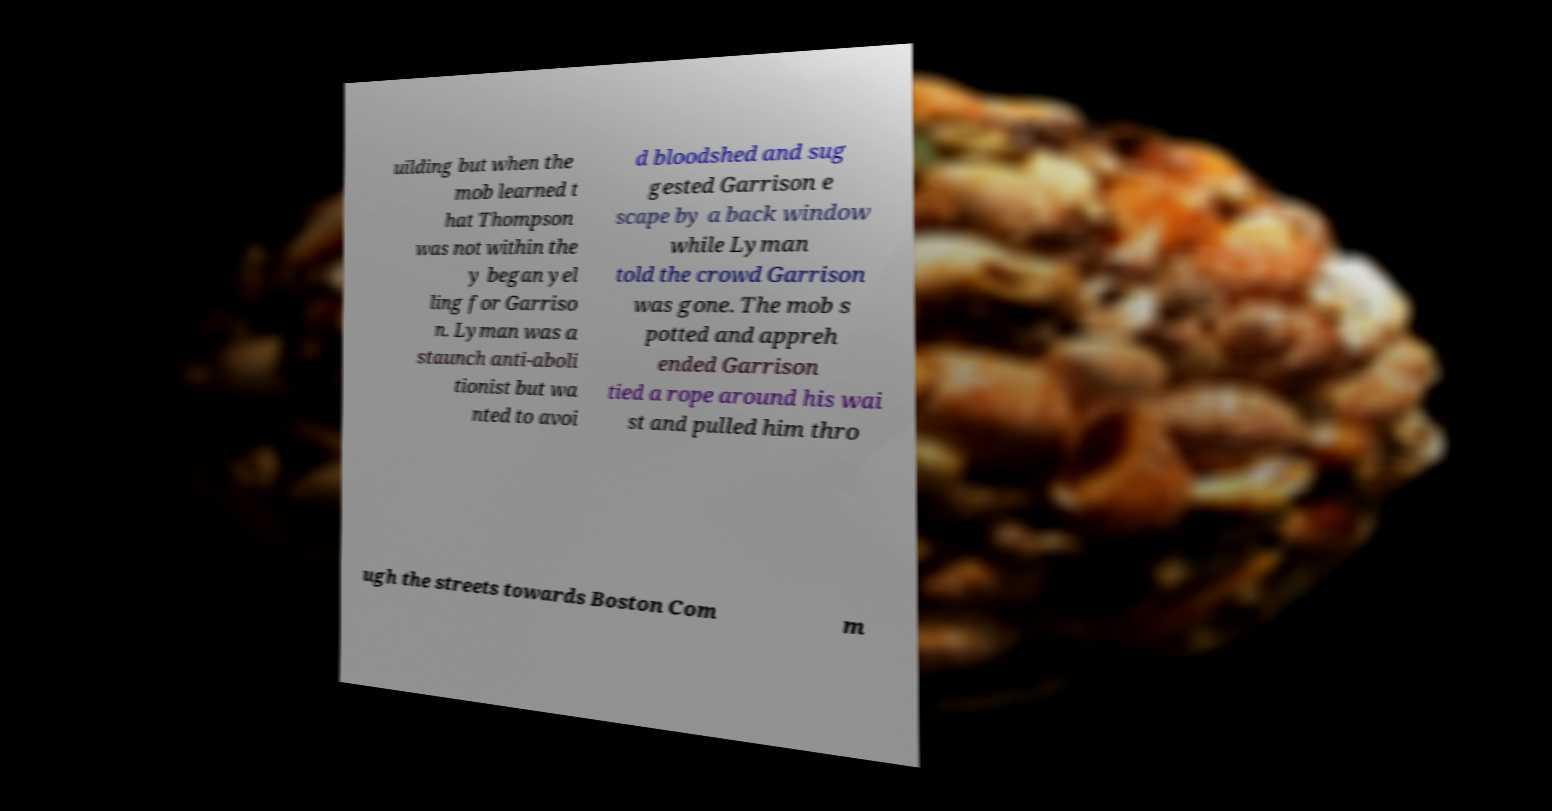Could you extract and type out the text from this image? uilding but when the mob learned t hat Thompson was not within the y began yel ling for Garriso n. Lyman was a staunch anti-aboli tionist but wa nted to avoi d bloodshed and sug gested Garrison e scape by a back window while Lyman told the crowd Garrison was gone. The mob s potted and appreh ended Garrison tied a rope around his wai st and pulled him thro ugh the streets towards Boston Com m 